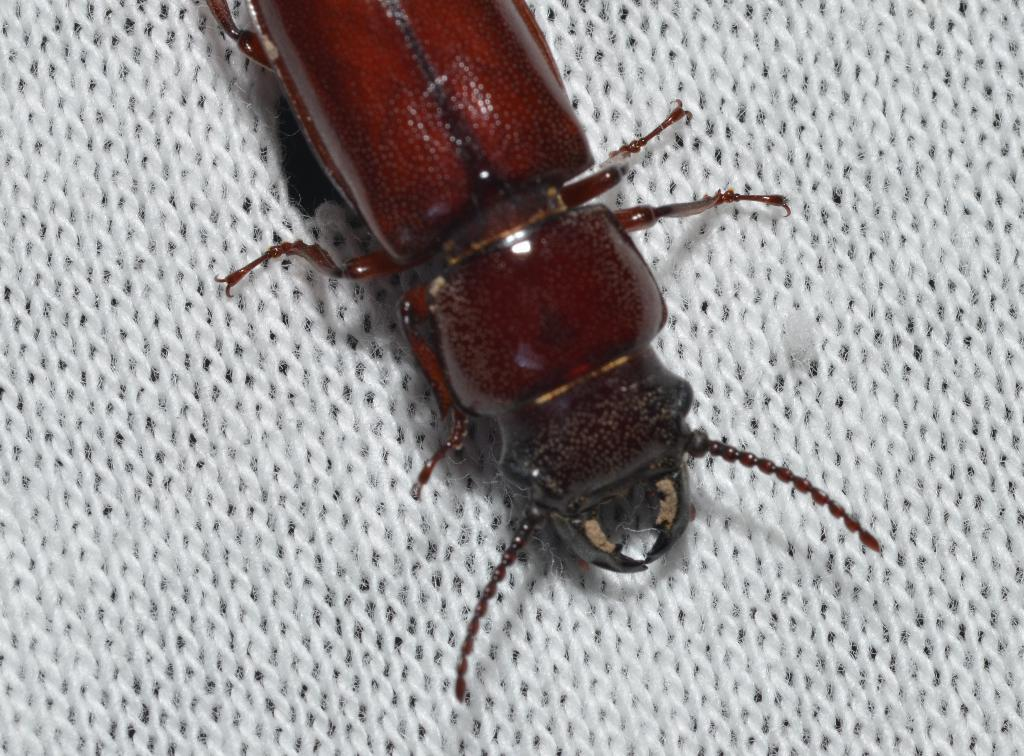What type of creature can be seen in the image? There is an insect in the image. What color is the insect? The insect is red in color. What is the insect resting on in the image? The insect is on a white cloth. How many knees are visible in the image? There are no knees visible in the image; it features an insect on a white cloth. What type of group is shown interacting with the insect in the image? There is no group present in the image; it only features an insect on a white cloth. 